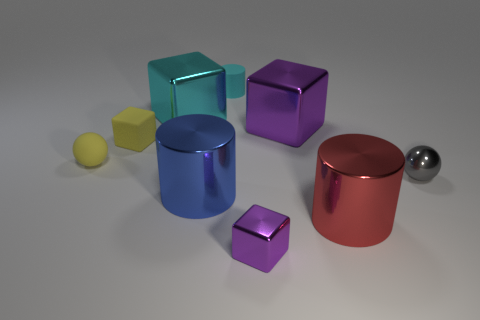Subtract all spheres. How many objects are left? 7 Subtract all big brown matte cylinders. Subtract all large purple blocks. How many objects are left? 8 Add 5 large purple metal objects. How many large purple metal objects are left? 6 Add 8 yellow metal cubes. How many yellow metal cubes exist? 8 Subtract 0 green spheres. How many objects are left? 9 